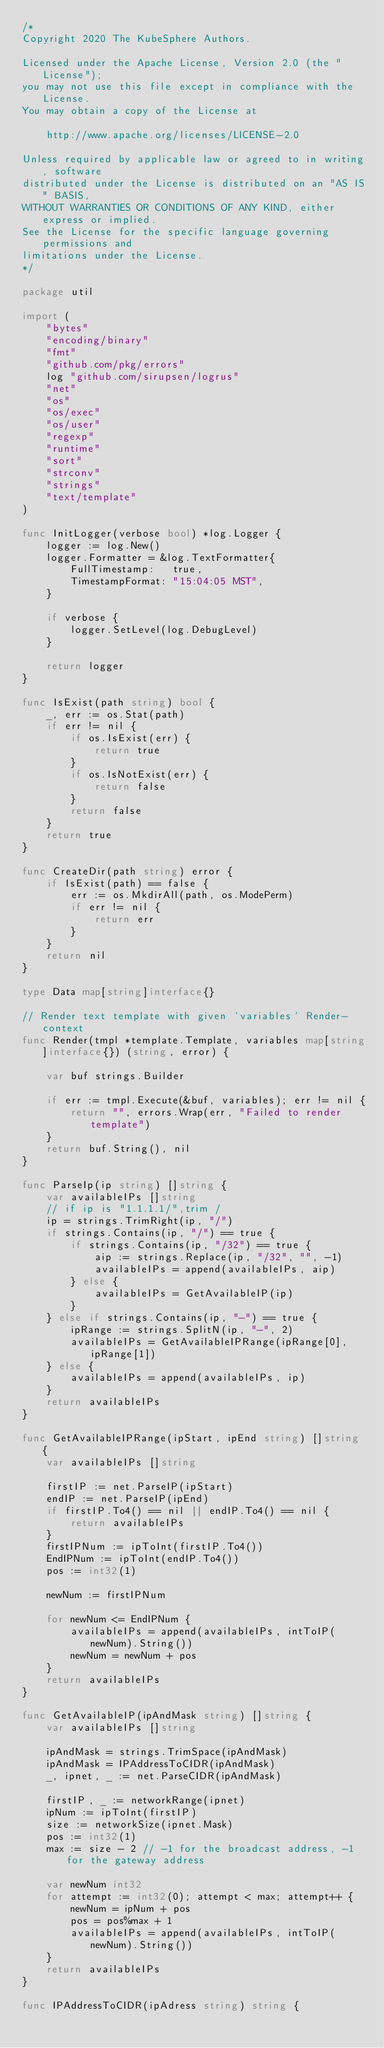Convert code to text. <code><loc_0><loc_0><loc_500><loc_500><_Go_>/*
Copyright 2020 The KubeSphere Authors.

Licensed under the Apache License, Version 2.0 (the "License");
you may not use this file except in compliance with the License.
You may obtain a copy of the License at

    http://www.apache.org/licenses/LICENSE-2.0

Unless required by applicable law or agreed to in writing, software
distributed under the License is distributed on an "AS IS" BASIS,
WITHOUT WARRANTIES OR CONDITIONS OF ANY KIND, either express or implied.
See the License for the specific language governing permissions and
limitations under the License.
*/

package util

import (
	"bytes"
	"encoding/binary"
	"fmt"
	"github.com/pkg/errors"
	log "github.com/sirupsen/logrus"
	"net"
	"os"
	"os/exec"
	"os/user"
	"regexp"
	"runtime"
	"sort"
	"strconv"
	"strings"
	"text/template"
)

func InitLogger(verbose bool) *log.Logger {
	logger := log.New()
	logger.Formatter = &log.TextFormatter{
		FullTimestamp:   true,
		TimestampFormat: "15:04:05 MST",
	}

	if verbose {
		logger.SetLevel(log.DebugLevel)
	}

	return logger
}

func IsExist(path string) bool {
	_, err := os.Stat(path)
	if err != nil {
		if os.IsExist(err) {
			return true
		}
		if os.IsNotExist(err) {
			return false
		}
		return false
	}
	return true
}

func CreateDir(path string) error {
	if IsExist(path) == false {
		err := os.MkdirAll(path, os.ModePerm)
		if err != nil {
			return err
		}
	}
	return nil
}

type Data map[string]interface{}

// Render text template with given `variables` Render-context
func Render(tmpl *template.Template, variables map[string]interface{}) (string, error) {

	var buf strings.Builder

	if err := tmpl.Execute(&buf, variables); err != nil {
		return "", errors.Wrap(err, "Failed to render template")
	}
	return buf.String(), nil
}

func ParseIp(ip string) []string {
	var availableIPs []string
	// if ip is "1.1.1.1/",trim /
	ip = strings.TrimRight(ip, "/")
	if strings.Contains(ip, "/") == true {
		if strings.Contains(ip, "/32") == true {
			aip := strings.Replace(ip, "/32", "", -1)
			availableIPs = append(availableIPs, aip)
		} else {
			availableIPs = GetAvailableIP(ip)
		}
	} else if strings.Contains(ip, "-") == true {
		ipRange := strings.SplitN(ip, "-", 2)
		availableIPs = GetAvailableIPRange(ipRange[0], ipRange[1])
	} else {
		availableIPs = append(availableIPs, ip)
	}
	return availableIPs
}

func GetAvailableIPRange(ipStart, ipEnd string) []string {
	var availableIPs []string

	firstIP := net.ParseIP(ipStart)
	endIP := net.ParseIP(ipEnd)
	if firstIP.To4() == nil || endIP.To4() == nil {
		return availableIPs
	}
	firstIPNum := ipToInt(firstIP.To4())
	EndIPNum := ipToInt(endIP.To4())
	pos := int32(1)

	newNum := firstIPNum

	for newNum <= EndIPNum {
		availableIPs = append(availableIPs, intToIP(newNum).String())
		newNum = newNum + pos
	}
	return availableIPs
}

func GetAvailableIP(ipAndMask string) []string {
	var availableIPs []string

	ipAndMask = strings.TrimSpace(ipAndMask)
	ipAndMask = IPAddressToCIDR(ipAndMask)
	_, ipnet, _ := net.ParseCIDR(ipAndMask)

	firstIP, _ := networkRange(ipnet)
	ipNum := ipToInt(firstIP)
	size := networkSize(ipnet.Mask)
	pos := int32(1)
	max := size - 2 // -1 for the broadcast address, -1 for the gateway address

	var newNum int32
	for attempt := int32(0); attempt < max; attempt++ {
		newNum = ipNum + pos
		pos = pos%max + 1
		availableIPs = append(availableIPs, intToIP(newNum).String())
	}
	return availableIPs
}

func IPAddressToCIDR(ipAdress string) string {</code> 